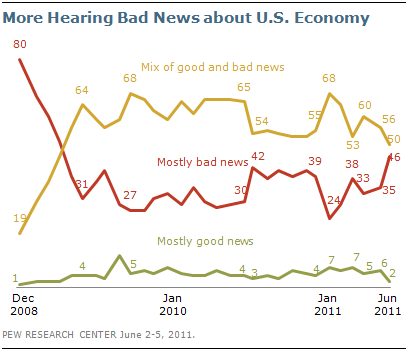Outline some significant characteristics in this image. The highest value for the red line is 80. The sum of the highest values of the red and yellow lines is 148. 